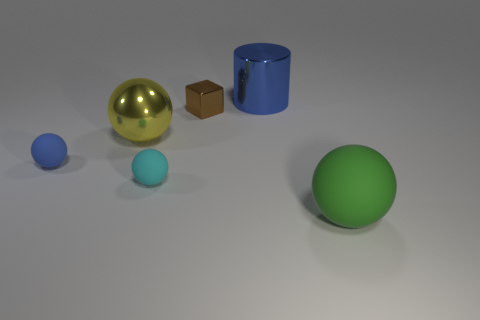Subtract 1 spheres. How many spheres are left? 3 Add 2 red metal spheres. How many objects exist? 8 Subtract all purple spheres. Subtract all green cylinders. How many spheres are left? 4 Subtract all cylinders. How many objects are left? 5 Add 5 brown shiny cubes. How many brown shiny cubes are left? 6 Add 6 cyan cylinders. How many cyan cylinders exist? 6 Subtract 0 red cylinders. How many objects are left? 6 Subtract all blue rubber balls. Subtract all big spheres. How many objects are left? 3 